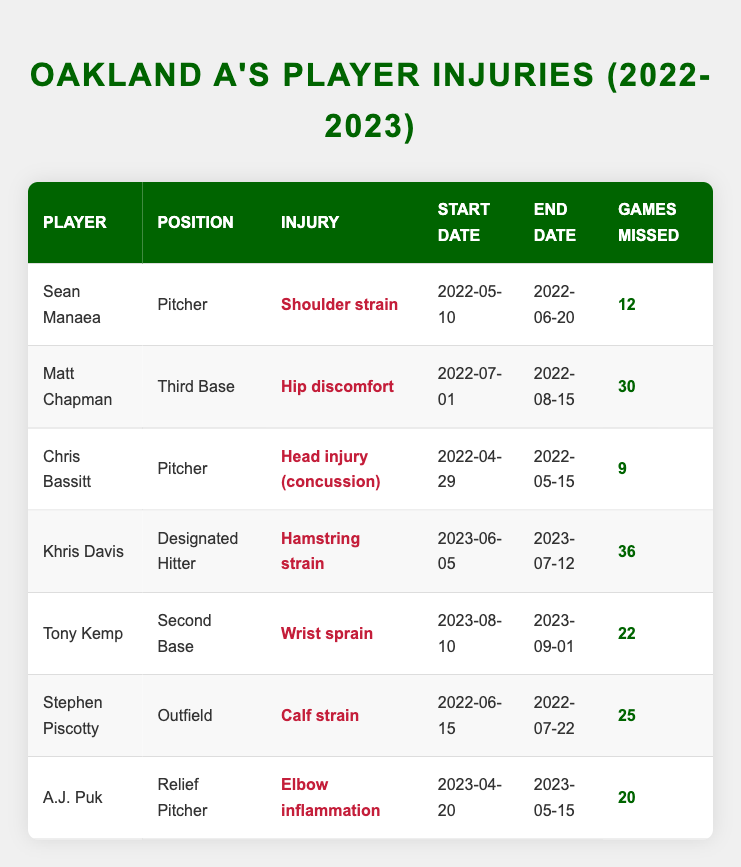What is the injury type for Khris Davis? In the table, we find the row for Khris Davis, which includes the "injury_type" column. It indicates that his injury type is "Hamstring strain."
Answer: Hamstring strain How many games did Matt Chapman miss due to his injury? Referring to Matt Chapman's row in the table, we see that the "games_missed" column shows he missed 30 games.
Answer: 30 Who missed the most games due to injury? To determine this, we compare the "games_missed" values for all players. The highest value is for Khris Davis with 36 games missed.
Answer: Khris Davis Is the injury type for Tony Kemp classified as a strain? Looking at the "injury_type" column for Tony Kemp, it states "Wrist sprain," which is indeed classified as a strain.
Answer: Yes What is the average number of games missed by all players? We will sum the "games_missed" values: 12 + 30 + 9 + 36 + 22 + 25 + 20 = 154. There are 7 players, so we divide 154 by 7, resulting in an average of approximately 22. The average number of games missed is thus 22.
Answer: 22 Which player returned from injury on July 12, 2023? By examining all end dates in the table, we find that Khris Davis's injury ended on July 12, 2023; therefore, he is the player who returned on that date.
Answer: Khris Davis Did any player miss 25 or more games due to injury? We scan the "games_missed" column to see if any player's count is 25 or higher. Both Matt Chapman (30) and Khris Davis (36) fit this criterion, confirming that at least one player did.
Answer: Yes How many different types of injuries are listed for the Oakland A's players in the table? We can identify the unique injury types in the table: Shoulder strain, Hip discomfort, Head injury (concussion), Hamstring strain, Wrist sprain, Calf strain, and Elbow inflammation. This gives us a total of 7 different types of injuries.
Answer: 7 